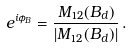Convert formula to latex. <formula><loc_0><loc_0><loc_500><loc_500>e ^ { i \phi _ { B } } = \frac { M _ { 1 2 } ( B _ { d } ) } { | M _ { 1 2 } ( B _ { d } ) | } \, .</formula> 